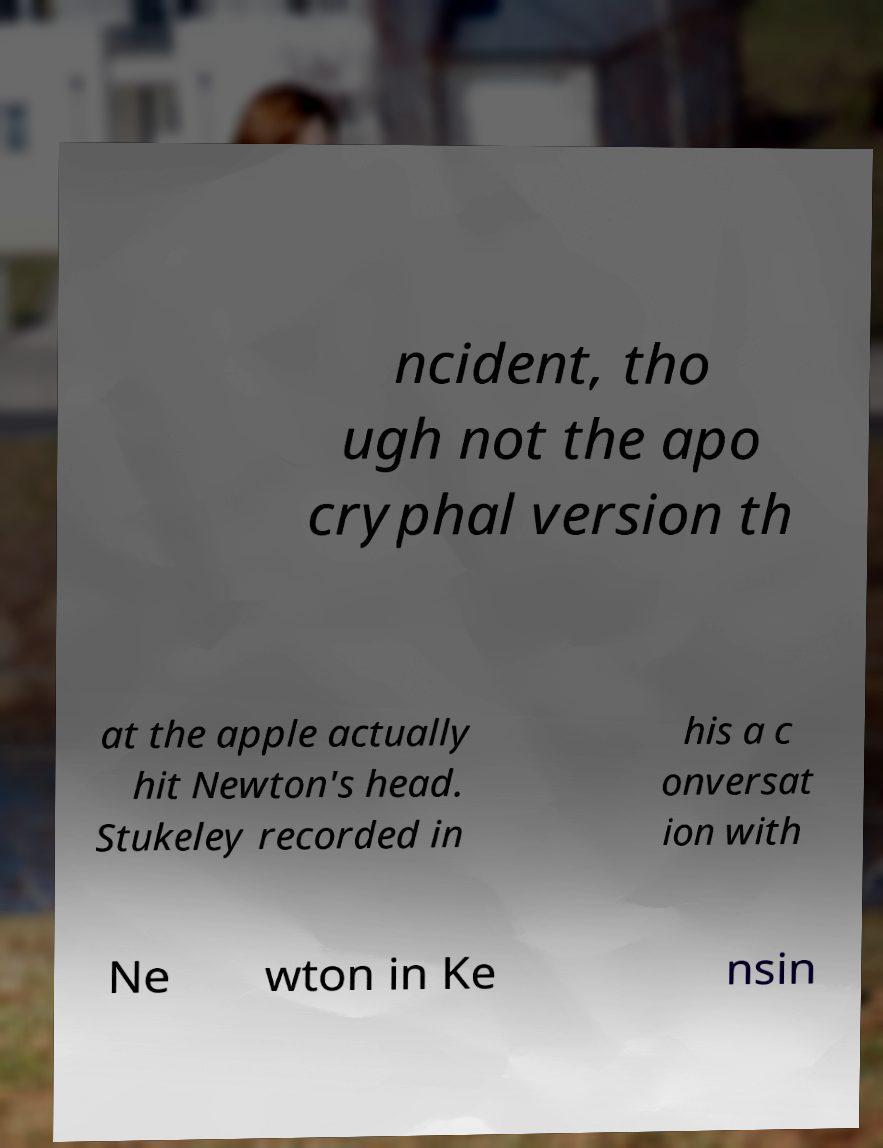What messages or text are displayed in this image? I need them in a readable, typed format. ncident, tho ugh not the apo cryphal version th at the apple actually hit Newton's head. Stukeley recorded in his a c onversat ion with Ne wton in Ke nsin 